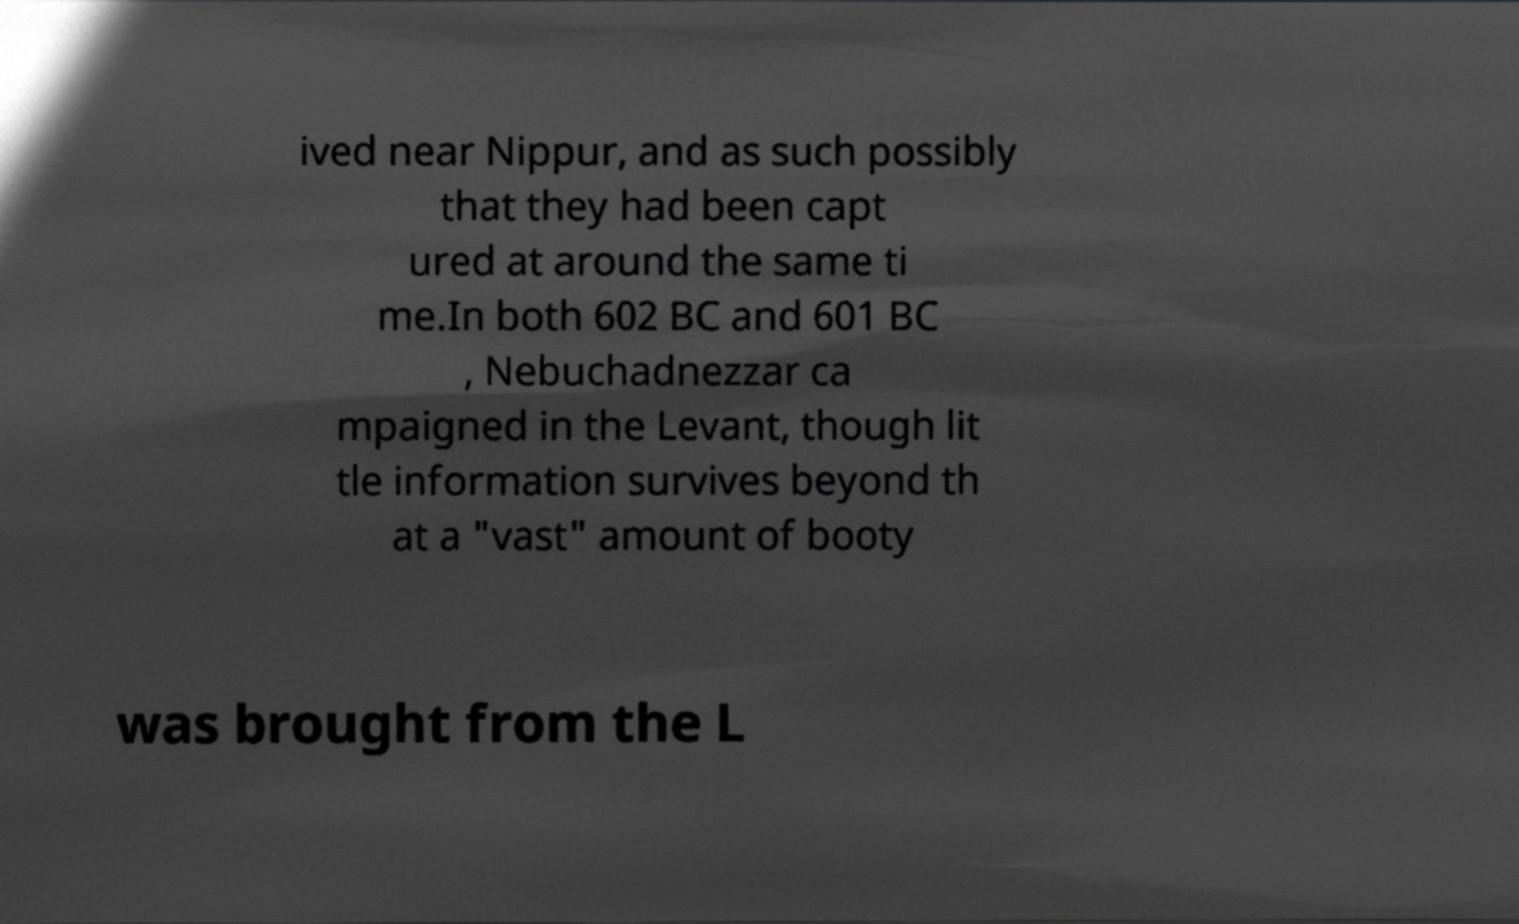I need the written content from this picture converted into text. Can you do that? ived near Nippur, and as such possibly that they had been capt ured at around the same ti me.In both 602 BC and 601 BC , Nebuchadnezzar ca mpaigned in the Levant, though lit tle information survives beyond th at a "vast" amount of booty was brought from the L 